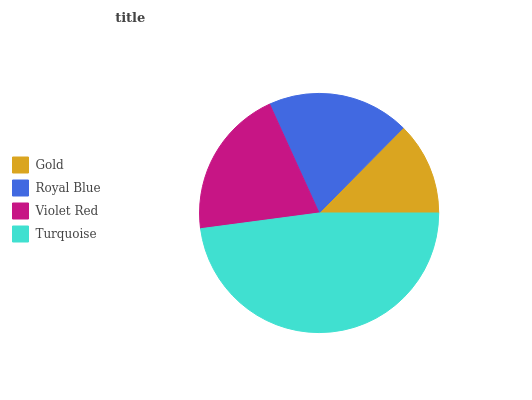Is Gold the minimum?
Answer yes or no. Yes. Is Turquoise the maximum?
Answer yes or no. Yes. Is Royal Blue the minimum?
Answer yes or no. No. Is Royal Blue the maximum?
Answer yes or no. No. Is Royal Blue greater than Gold?
Answer yes or no. Yes. Is Gold less than Royal Blue?
Answer yes or no. Yes. Is Gold greater than Royal Blue?
Answer yes or no. No. Is Royal Blue less than Gold?
Answer yes or no. No. Is Violet Red the high median?
Answer yes or no. Yes. Is Royal Blue the low median?
Answer yes or no. Yes. Is Gold the high median?
Answer yes or no. No. Is Turquoise the low median?
Answer yes or no. No. 